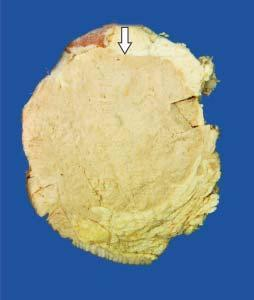what is the tumour somewhat delineated from?
Answer the question using a single word or phrase. Adjacent breast parenchyma as compared to irregular margin of idc 